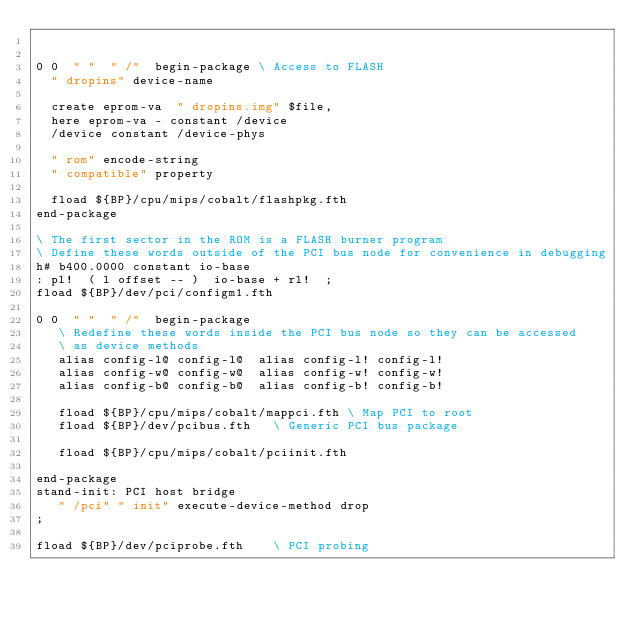<code> <loc_0><loc_0><loc_500><loc_500><_Forth_>

0 0  " "  " /"  begin-package	\ Access to FLASH
  " dropins" device-name

  create eprom-va  " dropins.img" $file,
  here eprom-va - constant /device
  /device constant /device-phys

  " rom" encode-string
  " compatible" property

  fload ${BP}/cpu/mips/cobalt/flashpkg.fth
end-package

\ The first sector in the ROM is a FLASH burner program
\ Define these words outside of the PCI bus node for convenience in debugging
h# b400.0000 constant io-base
: pl!  ( l offset -- )  io-base + rl!  ;
fload ${BP}/dev/pci/configm1.fth

0 0  " "  " /"  begin-package
   \ Redefine these words inside the PCI bus node so they can be accessed
   \ as device methods
   alias config-l@ config-l@  alias config-l! config-l!
   alias config-w@ config-w@  alias config-w! config-w!
   alias config-b@ config-b@  alias config-b! config-b!

   fload ${BP}/cpu/mips/cobalt/mappci.fth	\ Map PCI to root
   fload ${BP}/dev/pcibus.fth		\ Generic PCI bus package

   fload ${BP}/cpu/mips/cobalt/pciinit.fth

end-package
stand-init: PCI host bridge
   " /pci" " init" execute-device-method drop
;

fload ${BP}/dev/pciprobe.fth		\ PCI probing</code> 